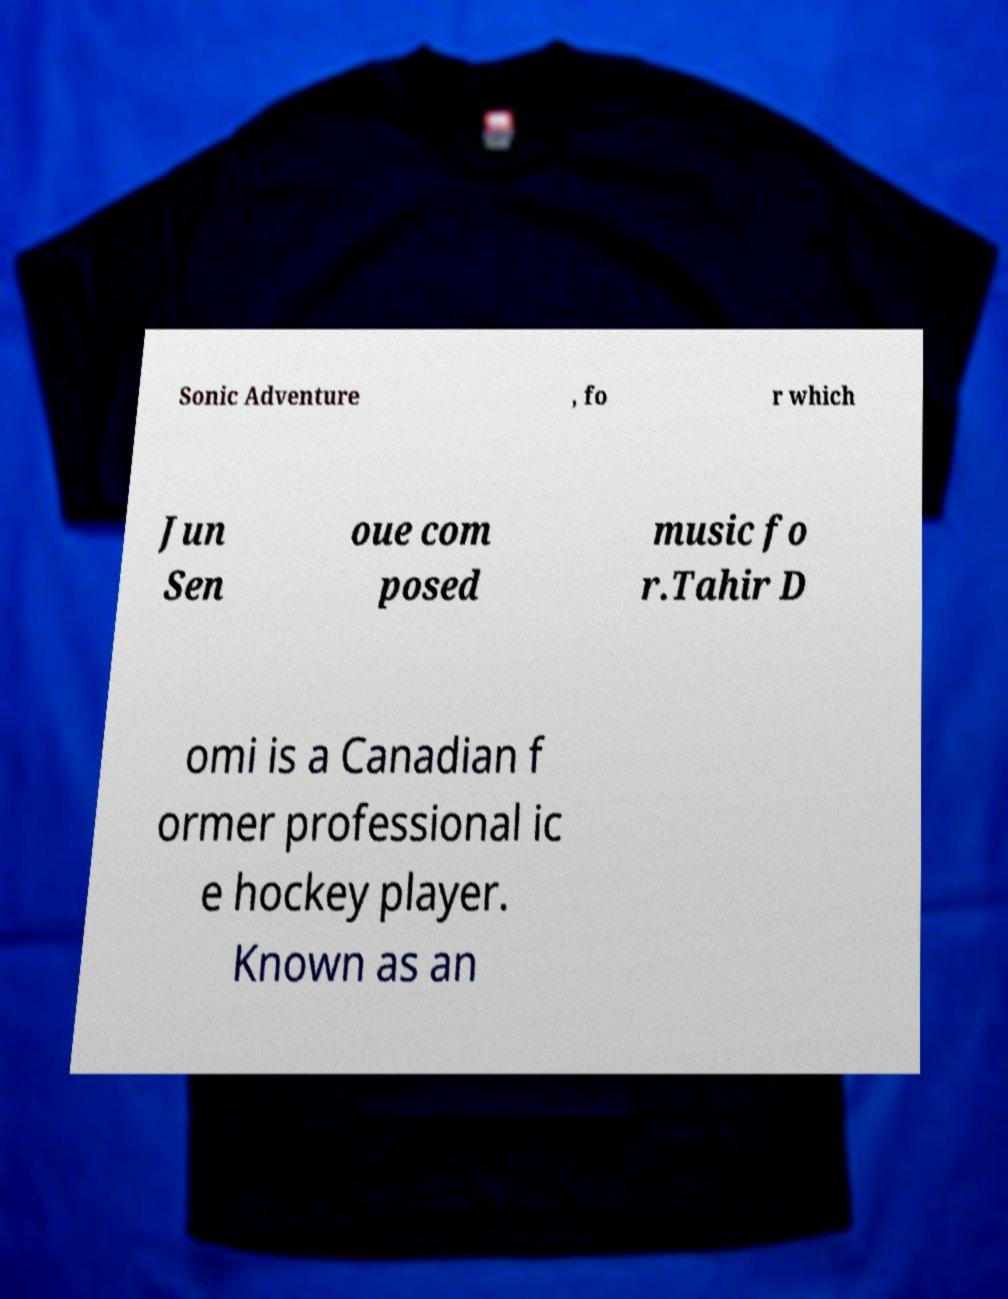Please read and relay the text visible in this image. What does it say? Sonic Adventure , fo r which Jun Sen oue com posed music fo r.Tahir D omi is a Canadian f ormer professional ic e hockey player. Known as an 